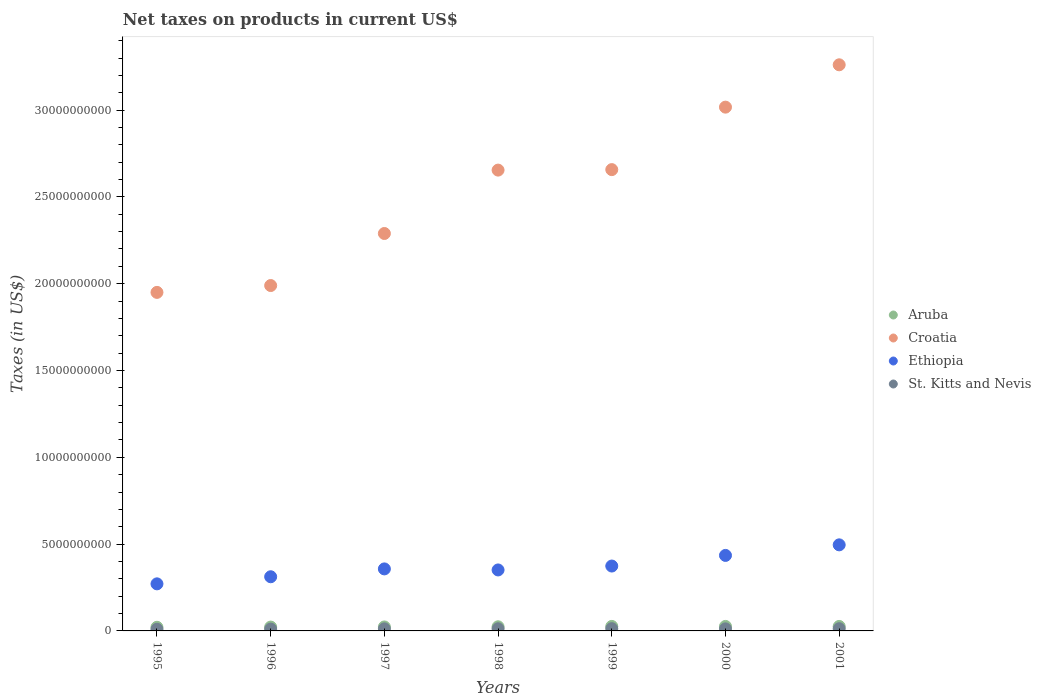Is the number of dotlines equal to the number of legend labels?
Provide a succinct answer. Yes. What is the net taxes on products in Croatia in 1995?
Make the answer very short. 1.95e+1. Across all years, what is the maximum net taxes on products in Aruba?
Your answer should be compact. 2.59e+08. Across all years, what is the minimum net taxes on products in Aruba?
Offer a very short reply. 2.09e+08. What is the total net taxes on products in Aruba in the graph?
Your response must be concise. 1.67e+09. What is the difference between the net taxes on products in Croatia in 2000 and that in 2001?
Keep it short and to the point. -2.44e+09. What is the difference between the net taxes on products in Croatia in 1995 and the net taxes on products in Ethiopia in 2001?
Your answer should be very brief. 1.45e+1. What is the average net taxes on products in Aruba per year?
Your response must be concise. 2.39e+08. In the year 1997, what is the difference between the net taxes on products in Ethiopia and net taxes on products in St. Kitts and Nevis?
Your answer should be compact. 3.45e+09. In how many years, is the net taxes on products in Aruba greater than 8000000000 US$?
Your answer should be very brief. 0. What is the ratio of the net taxes on products in Ethiopia in 1996 to that in 1999?
Offer a terse response. 0.83. Is the difference between the net taxes on products in Ethiopia in 1996 and 1999 greater than the difference between the net taxes on products in St. Kitts and Nevis in 1996 and 1999?
Make the answer very short. No. What is the difference between the highest and the second highest net taxes on products in St. Kitts and Nevis?
Your answer should be very brief. 2.08e+06. What is the difference between the highest and the lowest net taxes on products in St. Kitts and Nevis?
Offer a terse response. 3.42e+07. Is the sum of the net taxes on products in Croatia in 1997 and 2001 greater than the maximum net taxes on products in Ethiopia across all years?
Offer a terse response. Yes. Is it the case that in every year, the sum of the net taxes on products in St. Kitts and Nevis and net taxes on products in Ethiopia  is greater than the net taxes on products in Aruba?
Ensure brevity in your answer.  Yes. Does the net taxes on products in St. Kitts and Nevis monotonically increase over the years?
Provide a short and direct response. No. Is the net taxes on products in Ethiopia strictly greater than the net taxes on products in St. Kitts and Nevis over the years?
Give a very brief answer. Yes. Is the net taxes on products in St. Kitts and Nevis strictly less than the net taxes on products in Croatia over the years?
Keep it short and to the point. Yes. Does the graph contain grids?
Offer a very short reply. No. What is the title of the graph?
Your answer should be very brief. Net taxes on products in current US$. Does "Virgin Islands" appear as one of the legend labels in the graph?
Make the answer very short. No. What is the label or title of the Y-axis?
Keep it short and to the point. Taxes (in US$). What is the Taxes (in US$) in Aruba in 1995?
Make the answer very short. 2.09e+08. What is the Taxes (in US$) in Croatia in 1995?
Your answer should be compact. 1.95e+1. What is the Taxes (in US$) of Ethiopia in 1995?
Your response must be concise. 2.71e+09. What is the Taxes (in US$) in St. Kitts and Nevis in 1995?
Offer a very short reply. 9.47e+07. What is the Taxes (in US$) of Aruba in 1996?
Make the answer very short. 2.21e+08. What is the Taxes (in US$) of Croatia in 1996?
Give a very brief answer. 1.99e+1. What is the Taxes (in US$) in Ethiopia in 1996?
Make the answer very short. 3.12e+09. What is the Taxes (in US$) in St. Kitts and Nevis in 1996?
Provide a short and direct response. 1.05e+08. What is the Taxes (in US$) of Aruba in 1997?
Your answer should be compact. 2.29e+08. What is the Taxes (in US$) of Croatia in 1997?
Your answer should be compact. 2.29e+1. What is the Taxes (in US$) in Ethiopia in 1997?
Keep it short and to the point. 3.57e+09. What is the Taxes (in US$) of St. Kitts and Nevis in 1997?
Provide a succinct answer. 1.19e+08. What is the Taxes (in US$) of Aruba in 1998?
Provide a short and direct response. 2.38e+08. What is the Taxes (in US$) in Croatia in 1998?
Offer a very short reply. 2.65e+1. What is the Taxes (in US$) in Ethiopia in 1998?
Make the answer very short. 3.51e+09. What is the Taxes (in US$) of St. Kitts and Nevis in 1998?
Offer a terse response. 1.23e+08. What is the Taxes (in US$) of Aruba in 1999?
Make the answer very short. 2.59e+08. What is the Taxes (in US$) in Croatia in 1999?
Your answer should be very brief. 2.66e+1. What is the Taxes (in US$) of Ethiopia in 1999?
Offer a very short reply. 3.74e+09. What is the Taxes (in US$) in St. Kitts and Nevis in 1999?
Provide a succinct answer. 1.29e+08. What is the Taxes (in US$) in Aruba in 2000?
Your answer should be very brief. 2.59e+08. What is the Taxes (in US$) of Croatia in 2000?
Ensure brevity in your answer.  3.02e+1. What is the Taxes (in US$) in Ethiopia in 2000?
Your answer should be compact. 4.35e+09. What is the Taxes (in US$) in St. Kitts and Nevis in 2000?
Give a very brief answer. 1.19e+08. What is the Taxes (in US$) in Aruba in 2001?
Your answer should be compact. 2.58e+08. What is the Taxes (in US$) of Croatia in 2001?
Provide a succinct answer. 3.26e+1. What is the Taxes (in US$) in Ethiopia in 2001?
Offer a terse response. 4.96e+09. What is the Taxes (in US$) of St. Kitts and Nevis in 2001?
Ensure brevity in your answer.  1.27e+08. Across all years, what is the maximum Taxes (in US$) in Aruba?
Your answer should be compact. 2.59e+08. Across all years, what is the maximum Taxes (in US$) in Croatia?
Provide a short and direct response. 3.26e+1. Across all years, what is the maximum Taxes (in US$) in Ethiopia?
Ensure brevity in your answer.  4.96e+09. Across all years, what is the maximum Taxes (in US$) of St. Kitts and Nevis?
Offer a terse response. 1.29e+08. Across all years, what is the minimum Taxes (in US$) of Aruba?
Provide a short and direct response. 2.09e+08. Across all years, what is the minimum Taxes (in US$) of Croatia?
Give a very brief answer. 1.95e+1. Across all years, what is the minimum Taxes (in US$) of Ethiopia?
Keep it short and to the point. 2.71e+09. Across all years, what is the minimum Taxes (in US$) of St. Kitts and Nevis?
Provide a succinct answer. 9.47e+07. What is the total Taxes (in US$) in Aruba in the graph?
Provide a short and direct response. 1.67e+09. What is the total Taxes (in US$) of Croatia in the graph?
Provide a short and direct response. 1.78e+11. What is the total Taxes (in US$) in Ethiopia in the graph?
Provide a short and direct response. 2.60e+1. What is the total Taxes (in US$) of St. Kitts and Nevis in the graph?
Provide a succinct answer. 8.17e+08. What is the difference between the Taxes (in US$) of Aruba in 1995 and that in 1996?
Keep it short and to the point. -1.20e+07. What is the difference between the Taxes (in US$) of Croatia in 1995 and that in 1996?
Your answer should be compact. -3.94e+08. What is the difference between the Taxes (in US$) in Ethiopia in 1995 and that in 1996?
Offer a very short reply. -4.08e+08. What is the difference between the Taxes (in US$) in St. Kitts and Nevis in 1995 and that in 1996?
Provide a short and direct response. -1.04e+07. What is the difference between the Taxes (in US$) in Aruba in 1995 and that in 1997?
Provide a succinct answer. -2.00e+07. What is the difference between the Taxes (in US$) of Croatia in 1995 and that in 1997?
Give a very brief answer. -3.39e+09. What is the difference between the Taxes (in US$) in Ethiopia in 1995 and that in 1997?
Offer a very short reply. -8.61e+08. What is the difference between the Taxes (in US$) of St. Kitts and Nevis in 1995 and that in 1997?
Your answer should be very brief. -2.41e+07. What is the difference between the Taxes (in US$) in Aruba in 1995 and that in 1998?
Keep it short and to the point. -2.95e+07. What is the difference between the Taxes (in US$) in Croatia in 1995 and that in 1998?
Offer a very short reply. -7.04e+09. What is the difference between the Taxes (in US$) of Ethiopia in 1995 and that in 1998?
Offer a very short reply. -8.01e+08. What is the difference between the Taxes (in US$) of St. Kitts and Nevis in 1995 and that in 1998?
Your answer should be compact. -2.86e+07. What is the difference between the Taxes (in US$) in Aruba in 1995 and that in 1999?
Make the answer very short. -4.98e+07. What is the difference between the Taxes (in US$) in Croatia in 1995 and that in 1999?
Provide a succinct answer. -7.07e+09. What is the difference between the Taxes (in US$) in Ethiopia in 1995 and that in 1999?
Make the answer very short. -1.03e+09. What is the difference between the Taxes (in US$) of St. Kitts and Nevis in 1995 and that in 1999?
Your answer should be compact. -3.42e+07. What is the difference between the Taxes (in US$) in Aruba in 1995 and that in 2000?
Your answer should be compact. -4.98e+07. What is the difference between the Taxes (in US$) in Croatia in 1995 and that in 2000?
Make the answer very short. -1.07e+1. What is the difference between the Taxes (in US$) of Ethiopia in 1995 and that in 2000?
Make the answer very short. -1.64e+09. What is the difference between the Taxes (in US$) of St. Kitts and Nevis in 1995 and that in 2000?
Ensure brevity in your answer.  -2.39e+07. What is the difference between the Taxes (in US$) of Aruba in 1995 and that in 2001?
Keep it short and to the point. -4.92e+07. What is the difference between the Taxes (in US$) of Croatia in 1995 and that in 2001?
Your answer should be very brief. -1.31e+1. What is the difference between the Taxes (in US$) in Ethiopia in 1995 and that in 2001?
Ensure brevity in your answer.  -2.25e+09. What is the difference between the Taxes (in US$) of St. Kitts and Nevis in 1995 and that in 2001?
Keep it short and to the point. -3.21e+07. What is the difference between the Taxes (in US$) of Aruba in 1996 and that in 1997?
Provide a short and direct response. -8.00e+06. What is the difference between the Taxes (in US$) in Croatia in 1996 and that in 1997?
Offer a very short reply. -3.00e+09. What is the difference between the Taxes (in US$) in Ethiopia in 1996 and that in 1997?
Offer a very short reply. -4.52e+08. What is the difference between the Taxes (in US$) of St. Kitts and Nevis in 1996 and that in 1997?
Ensure brevity in your answer.  -1.37e+07. What is the difference between the Taxes (in US$) in Aruba in 1996 and that in 1998?
Provide a short and direct response. -1.75e+07. What is the difference between the Taxes (in US$) of Croatia in 1996 and that in 1998?
Provide a short and direct response. -6.65e+09. What is the difference between the Taxes (in US$) in Ethiopia in 1996 and that in 1998?
Give a very brief answer. -3.92e+08. What is the difference between the Taxes (in US$) in St. Kitts and Nevis in 1996 and that in 1998?
Offer a very short reply. -1.82e+07. What is the difference between the Taxes (in US$) in Aruba in 1996 and that in 1999?
Provide a succinct answer. -3.78e+07. What is the difference between the Taxes (in US$) of Croatia in 1996 and that in 1999?
Give a very brief answer. -6.68e+09. What is the difference between the Taxes (in US$) of Ethiopia in 1996 and that in 1999?
Ensure brevity in your answer.  -6.17e+08. What is the difference between the Taxes (in US$) of St. Kitts and Nevis in 1996 and that in 1999?
Make the answer very short. -2.38e+07. What is the difference between the Taxes (in US$) of Aruba in 1996 and that in 2000?
Make the answer very short. -3.78e+07. What is the difference between the Taxes (in US$) in Croatia in 1996 and that in 2000?
Your response must be concise. -1.03e+1. What is the difference between the Taxes (in US$) of Ethiopia in 1996 and that in 2000?
Your answer should be very brief. -1.23e+09. What is the difference between the Taxes (in US$) in St. Kitts and Nevis in 1996 and that in 2000?
Give a very brief answer. -1.35e+07. What is the difference between the Taxes (in US$) of Aruba in 1996 and that in 2001?
Give a very brief answer. -3.72e+07. What is the difference between the Taxes (in US$) in Croatia in 1996 and that in 2001?
Provide a short and direct response. -1.27e+1. What is the difference between the Taxes (in US$) in Ethiopia in 1996 and that in 2001?
Your answer should be very brief. -1.84e+09. What is the difference between the Taxes (in US$) of St. Kitts and Nevis in 1996 and that in 2001?
Give a very brief answer. -2.17e+07. What is the difference between the Taxes (in US$) in Aruba in 1997 and that in 1998?
Offer a very short reply. -9.46e+06. What is the difference between the Taxes (in US$) of Croatia in 1997 and that in 1998?
Your response must be concise. -3.65e+09. What is the difference between the Taxes (in US$) in Ethiopia in 1997 and that in 1998?
Provide a succinct answer. 5.98e+07. What is the difference between the Taxes (in US$) of St. Kitts and Nevis in 1997 and that in 1998?
Ensure brevity in your answer.  -4.53e+06. What is the difference between the Taxes (in US$) in Aruba in 1997 and that in 1999?
Your answer should be very brief. -2.98e+07. What is the difference between the Taxes (in US$) of Croatia in 1997 and that in 1999?
Offer a terse response. -3.68e+09. What is the difference between the Taxes (in US$) of Ethiopia in 1997 and that in 1999?
Keep it short and to the point. -1.65e+08. What is the difference between the Taxes (in US$) of St. Kitts and Nevis in 1997 and that in 1999?
Give a very brief answer. -1.01e+07. What is the difference between the Taxes (in US$) in Aruba in 1997 and that in 2000?
Your response must be concise. -2.98e+07. What is the difference between the Taxes (in US$) in Croatia in 1997 and that in 2000?
Offer a very short reply. -7.28e+09. What is the difference between the Taxes (in US$) of Ethiopia in 1997 and that in 2000?
Your response must be concise. -7.77e+08. What is the difference between the Taxes (in US$) in Aruba in 1997 and that in 2001?
Your response must be concise. -2.92e+07. What is the difference between the Taxes (in US$) of Croatia in 1997 and that in 2001?
Offer a very short reply. -9.72e+09. What is the difference between the Taxes (in US$) of Ethiopia in 1997 and that in 2001?
Ensure brevity in your answer.  -1.39e+09. What is the difference between the Taxes (in US$) in St. Kitts and Nevis in 1997 and that in 2001?
Give a very brief answer. -8.01e+06. What is the difference between the Taxes (in US$) of Aruba in 1998 and that in 1999?
Give a very brief answer. -2.03e+07. What is the difference between the Taxes (in US$) of Croatia in 1998 and that in 1999?
Give a very brief answer. -2.80e+07. What is the difference between the Taxes (in US$) of Ethiopia in 1998 and that in 1999?
Your response must be concise. -2.25e+08. What is the difference between the Taxes (in US$) of St. Kitts and Nevis in 1998 and that in 1999?
Your response must be concise. -5.56e+06. What is the difference between the Taxes (in US$) of Aruba in 1998 and that in 2000?
Give a very brief answer. -2.03e+07. What is the difference between the Taxes (in US$) of Croatia in 1998 and that in 2000?
Keep it short and to the point. -3.63e+09. What is the difference between the Taxes (in US$) of Ethiopia in 1998 and that in 2000?
Your answer should be compact. -8.37e+08. What is the difference between the Taxes (in US$) of St. Kitts and Nevis in 1998 and that in 2000?
Give a very brief answer. 4.72e+06. What is the difference between the Taxes (in US$) in Aruba in 1998 and that in 2001?
Keep it short and to the point. -1.97e+07. What is the difference between the Taxes (in US$) in Croatia in 1998 and that in 2001?
Provide a succinct answer. -6.07e+09. What is the difference between the Taxes (in US$) of Ethiopia in 1998 and that in 2001?
Offer a very short reply. -1.45e+09. What is the difference between the Taxes (in US$) of St. Kitts and Nevis in 1998 and that in 2001?
Your answer should be compact. -3.48e+06. What is the difference between the Taxes (in US$) of Aruba in 1999 and that in 2000?
Your answer should be very brief. 0. What is the difference between the Taxes (in US$) of Croatia in 1999 and that in 2000?
Offer a terse response. -3.60e+09. What is the difference between the Taxes (in US$) in Ethiopia in 1999 and that in 2000?
Offer a very short reply. -6.12e+08. What is the difference between the Taxes (in US$) of St. Kitts and Nevis in 1999 and that in 2000?
Offer a terse response. 1.03e+07. What is the difference between the Taxes (in US$) in Aruba in 1999 and that in 2001?
Your response must be concise. 5.80e+05. What is the difference between the Taxes (in US$) of Croatia in 1999 and that in 2001?
Provide a short and direct response. -6.04e+09. What is the difference between the Taxes (in US$) of Ethiopia in 1999 and that in 2001?
Offer a terse response. -1.22e+09. What is the difference between the Taxes (in US$) of St. Kitts and Nevis in 1999 and that in 2001?
Offer a terse response. 2.08e+06. What is the difference between the Taxes (in US$) of Aruba in 2000 and that in 2001?
Make the answer very short. 5.80e+05. What is the difference between the Taxes (in US$) of Croatia in 2000 and that in 2001?
Keep it short and to the point. -2.44e+09. What is the difference between the Taxes (in US$) of Ethiopia in 2000 and that in 2001?
Ensure brevity in your answer.  -6.09e+08. What is the difference between the Taxes (in US$) in St. Kitts and Nevis in 2000 and that in 2001?
Ensure brevity in your answer.  -8.20e+06. What is the difference between the Taxes (in US$) of Aruba in 1995 and the Taxes (in US$) of Croatia in 1996?
Keep it short and to the point. -1.97e+1. What is the difference between the Taxes (in US$) in Aruba in 1995 and the Taxes (in US$) in Ethiopia in 1996?
Offer a very short reply. -2.91e+09. What is the difference between the Taxes (in US$) of Aruba in 1995 and the Taxes (in US$) of St. Kitts and Nevis in 1996?
Your response must be concise. 1.04e+08. What is the difference between the Taxes (in US$) in Croatia in 1995 and the Taxes (in US$) in Ethiopia in 1996?
Make the answer very short. 1.64e+1. What is the difference between the Taxes (in US$) of Croatia in 1995 and the Taxes (in US$) of St. Kitts and Nevis in 1996?
Keep it short and to the point. 1.94e+1. What is the difference between the Taxes (in US$) in Ethiopia in 1995 and the Taxes (in US$) in St. Kitts and Nevis in 1996?
Your response must be concise. 2.61e+09. What is the difference between the Taxes (in US$) of Aruba in 1995 and the Taxes (in US$) of Croatia in 1997?
Your answer should be very brief. -2.27e+1. What is the difference between the Taxes (in US$) in Aruba in 1995 and the Taxes (in US$) in Ethiopia in 1997?
Provide a short and direct response. -3.36e+09. What is the difference between the Taxes (in US$) in Aruba in 1995 and the Taxes (in US$) in St. Kitts and Nevis in 1997?
Make the answer very short. 9.02e+07. What is the difference between the Taxes (in US$) in Croatia in 1995 and the Taxes (in US$) in Ethiopia in 1997?
Your response must be concise. 1.59e+1. What is the difference between the Taxes (in US$) in Croatia in 1995 and the Taxes (in US$) in St. Kitts and Nevis in 1997?
Provide a succinct answer. 1.94e+1. What is the difference between the Taxes (in US$) of Ethiopia in 1995 and the Taxes (in US$) of St. Kitts and Nevis in 1997?
Your answer should be compact. 2.59e+09. What is the difference between the Taxes (in US$) of Aruba in 1995 and the Taxes (in US$) of Croatia in 1998?
Offer a terse response. -2.63e+1. What is the difference between the Taxes (in US$) of Aruba in 1995 and the Taxes (in US$) of Ethiopia in 1998?
Provide a short and direct response. -3.30e+09. What is the difference between the Taxes (in US$) in Aruba in 1995 and the Taxes (in US$) in St. Kitts and Nevis in 1998?
Keep it short and to the point. 8.56e+07. What is the difference between the Taxes (in US$) in Croatia in 1995 and the Taxes (in US$) in Ethiopia in 1998?
Your response must be concise. 1.60e+1. What is the difference between the Taxes (in US$) of Croatia in 1995 and the Taxes (in US$) of St. Kitts and Nevis in 1998?
Make the answer very short. 1.94e+1. What is the difference between the Taxes (in US$) in Ethiopia in 1995 and the Taxes (in US$) in St. Kitts and Nevis in 1998?
Offer a terse response. 2.59e+09. What is the difference between the Taxes (in US$) of Aruba in 1995 and the Taxes (in US$) of Croatia in 1999?
Your response must be concise. -2.64e+1. What is the difference between the Taxes (in US$) in Aruba in 1995 and the Taxes (in US$) in Ethiopia in 1999?
Ensure brevity in your answer.  -3.53e+09. What is the difference between the Taxes (in US$) of Aruba in 1995 and the Taxes (in US$) of St. Kitts and Nevis in 1999?
Provide a succinct answer. 8.01e+07. What is the difference between the Taxes (in US$) of Croatia in 1995 and the Taxes (in US$) of Ethiopia in 1999?
Ensure brevity in your answer.  1.58e+1. What is the difference between the Taxes (in US$) of Croatia in 1995 and the Taxes (in US$) of St. Kitts and Nevis in 1999?
Your answer should be very brief. 1.94e+1. What is the difference between the Taxes (in US$) in Ethiopia in 1995 and the Taxes (in US$) in St. Kitts and Nevis in 1999?
Offer a very short reply. 2.58e+09. What is the difference between the Taxes (in US$) in Aruba in 1995 and the Taxes (in US$) in Croatia in 2000?
Offer a terse response. -3.00e+1. What is the difference between the Taxes (in US$) in Aruba in 1995 and the Taxes (in US$) in Ethiopia in 2000?
Ensure brevity in your answer.  -4.14e+09. What is the difference between the Taxes (in US$) in Aruba in 1995 and the Taxes (in US$) in St. Kitts and Nevis in 2000?
Your answer should be compact. 9.04e+07. What is the difference between the Taxes (in US$) of Croatia in 1995 and the Taxes (in US$) of Ethiopia in 2000?
Give a very brief answer. 1.52e+1. What is the difference between the Taxes (in US$) in Croatia in 1995 and the Taxes (in US$) in St. Kitts and Nevis in 2000?
Your answer should be compact. 1.94e+1. What is the difference between the Taxes (in US$) of Ethiopia in 1995 and the Taxes (in US$) of St. Kitts and Nevis in 2000?
Make the answer very short. 2.59e+09. What is the difference between the Taxes (in US$) in Aruba in 1995 and the Taxes (in US$) in Croatia in 2001?
Make the answer very short. -3.24e+1. What is the difference between the Taxes (in US$) in Aruba in 1995 and the Taxes (in US$) in Ethiopia in 2001?
Ensure brevity in your answer.  -4.75e+09. What is the difference between the Taxes (in US$) of Aruba in 1995 and the Taxes (in US$) of St. Kitts and Nevis in 2001?
Keep it short and to the point. 8.22e+07. What is the difference between the Taxes (in US$) of Croatia in 1995 and the Taxes (in US$) of Ethiopia in 2001?
Make the answer very short. 1.45e+1. What is the difference between the Taxes (in US$) of Croatia in 1995 and the Taxes (in US$) of St. Kitts and Nevis in 2001?
Your answer should be very brief. 1.94e+1. What is the difference between the Taxes (in US$) of Ethiopia in 1995 and the Taxes (in US$) of St. Kitts and Nevis in 2001?
Your response must be concise. 2.58e+09. What is the difference between the Taxes (in US$) in Aruba in 1996 and the Taxes (in US$) in Croatia in 1997?
Provide a short and direct response. -2.27e+1. What is the difference between the Taxes (in US$) of Aruba in 1996 and the Taxes (in US$) of Ethiopia in 1997?
Make the answer very short. -3.35e+09. What is the difference between the Taxes (in US$) in Aruba in 1996 and the Taxes (in US$) in St. Kitts and Nevis in 1997?
Offer a very short reply. 1.02e+08. What is the difference between the Taxes (in US$) of Croatia in 1996 and the Taxes (in US$) of Ethiopia in 1997?
Offer a terse response. 1.63e+1. What is the difference between the Taxes (in US$) in Croatia in 1996 and the Taxes (in US$) in St. Kitts and Nevis in 1997?
Offer a terse response. 1.98e+1. What is the difference between the Taxes (in US$) of Ethiopia in 1996 and the Taxes (in US$) of St. Kitts and Nevis in 1997?
Ensure brevity in your answer.  3.00e+09. What is the difference between the Taxes (in US$) of Aruba in 1996 and the Taxes (in US$) of Croatia in 1998?
Ensure brevity in your answer.  -2.63e+1. What is the difference between the Taxes (in US$) of Aruba in 1996 and the Taxes (in US$) of Ethiopia in 1998?
Give a very brief answer. -3.29e+09. What is the difference between the Taxes (in US$) of Aruba in 1996 and the Taxes (in US$) of St. Kitts and Nevis in 1998?
Your response must be concise. 9.76e+07. What is the difference between the Taxes (in US$) in Croatia in 1996 and the Taxes (in US$) in Ethiopia in 1998?
Keep it short and to the point. 1.64e+1. What is the difference between the Taxes (in US$) of Croatia in 1996 and the Taxes (in US$) of St. Kitts and Nevis in 1998?
Ensure brevity in your answer.  1.98e+1. What is the difference between the Taxes (in US$) in Ethiopia in 1996 and the Taxes (in US$) in St. Kitts and Nevis in 1998?
Provide a succinct answer. 3.00e+09. What is the difference between the Taxes (in US$) in Aruba in 1996 and the Taxes (in US$) in Croatia in 1999?
Make the answer very short. -2.63e+1. What is the difference between the Taxes (in US$) of Aruba in 1996 and the Taxes (in US$) of Ethiopia in 1999?
Make the answer very short. -3.52e+09. What is the difference between the Taxes (in US$) in Aruba in 1996 and the Taxes (in US$) in St. Kitts and Nevis in 1999?
Your answer should be very brief. 9.21e+07. What is the difference between the Taxes (in US$) of Croatia in 1996 and the Taxes (in US$) of Ethiopia in 1999?
Offer a terse response. 1.62e+1. What is the difference between the Taxes (in US$) of Croatia in 1996 and the Taxes (in US$) of St. Kitts and Nevis in 1999?
Offer a terse response. 1.98e+1. What is the difference between the Taxes (in US$) in Ethiopia in 1996 and the Taxes (in US$) in St. Kitts and Nevis in 1999?
Offer a very short reply. 2.99e+09. What is the difference between the Taxes (in US$) in Aruba in 1996 and the Taxes (in US$) in Croatia in 2000?
Offer a terse response. -2.99e+1. What is the difference between the Taxes (in US$) of Aruba in 1996 and the Taxes (in US$) of Ethiopia in 2000?
Offer a terse response. -4.13e+09. What is the difference between the Taxes (in US$) in Aruba in 1996 and the Taxes (in US$) in St. Kitts and Nevis in 2000?
Ensure brevity in your answer.  1.02e+08. What is the difference between the Taxes (in US$) in Croatia in 1996 and the Taxes (in US$) in Ethiopia in 2000?
Your answer should be compact. 1.55e+1. What is the difference between the Taxes (in US$) in Croatia in 1996 and the Taxes (in US$) in St. Kitts and Nevis in 2000?
Make the answer very short. 1.98e+1. What is the difference between the Taxes (in US$) in Ethiopia in 1996 and the Taxes (in US$) in St. Kitts and Nevis in 2000?
Provide a succinct answer. 3.00e+09. What is the difference between the Taxes (in US$) in Aruba in 1996 and the Taxes (in US$) in Croatia in 2001?
Provide a succinct answer. -3.24e+1. What is the difference between the Taxes (in US$) of Aruba in 1996 and the Taxes (in US$) of Ethiopia in 2001?
Ensure brevity in your answer.  -4.74e+09. What is the difference between the Taxes (in US$) in Aruba in 1996 and the Taxes (in US$) in St. Kitts and Nevis in 2001?
Give a very brief answer. 9.42e+07. What is the difference between the Taxes (in US$) in Croatia in 1996 and the Taxes (in US$) in Ethiopia in 2001?
Your response must be concise. 1.49e+1. What is the difference between the Taxes (in US$) in Croatia in 1996 and the Taxes (in US$) in St. Kitts and Nevis in 2001?
Provide a succinct answer. 1.98e+1. What is the difference between the Taxes (in US$) in Ethiopia in 1996 and the Taxes (in US$) in St. Kitts and Nevis in 2001?
Make the answer very short. 2.99e+09. What is the difference between the Taxes (in US$) in Aruba in 1997 and the Taxes (in US$) in Croatia in 1998?
Your answer should be compact. -2.63e+1. What is the difference between the Taxes (in US$) of Aruba in 1997 and the Taxes (in US$) of Ethiopia in 1998?
Provide a succinct answer. -3.28e+09. What is the difference between the Taxes (in US$) in Aruba in 1997 and the Taxes (in US$) in St. Kitts and Nevis in 1998?
Keep it short and to the point. 1.06e+08. What is the difference between the Taxes (in US$) of Croatia in 1997 and the Taxes (in US$) of Ethiopia in 1998?
Offer a terse response. 1.94e+1. What is the difference between the Taxes (in US$) of Croatia in 1997 and the Taxes (in US$) of St. Kitts and Nevis in 1998?
Ensure brevity in your answer.  2.28e+1. What is the difference between the Taxes (in US$) of Ethiopia in 1997 and the Taxes (in US$) of St. Kitts and Nevis in 1998?
Offer a terse response. 3.45e+09. What is the difference between the Taxes (in US$) of Aruba in 1997 and the Taxes (in US$) of Croatia in 1999?
Your answer should be very brief. -2.63e+1. What is the difference between the Taxes (in US$) of Aruba in 1997 and the Taxes (in US$) of Ethiopia in 1999?
Make the answer very short. -3.51e+09. What is the difference between the Taxes (in US$) in Aruba in 1997 and the Taxes (in US$) in St. Kitts and Nevis in 1999?
Offer a terse response. 1.00e+08. What is the difference between the Taxes (in US$) of Croatia in 1997 and the Taxes (in US$) of Ethiopia in 1999?
Ensure brevity in your answer.  1.92e+1. What is the difference between the Taxes (in US$) of Croatia in 1997 and the Taxes (in US$) of St. Kitts and Nevis in 1999?
Provide a short and direct response. 2.28e+1. What is the difference between the Taxes (in US$) of Ethiopia in 1997 and the Taxes (in US$) of St. Kitts and Nevis in 1999?
Your response must be concise. 3.44e+09. What is the difference between the Taxes (in US$) of Aruba in 1997 and the Taxes (in US$) of Croatia in 2000?
Make the answer very short. -2.99e+1. What is the difference between the Taxes (in US$) of Aruba in 1997 and the Taxes (in US$) of Ethiopia in 2000?
Your answer should be compact. -4.12e+09. What is the difference between the Taxes (in US$) in Aruba in 1997 and the Taxes (in US$) in St. Kitts and Nevis in 2000?
Offer a very short reply. 1.10e+08. What is the difference between the Taxes (in US$) in Croatia in 1997 and the Taxes (in US$) in Ethiopia in 2000?
Give a very brief answer. 1.85e+1. What is the difference between the Taxes (in US$) in Croatia in 1997 and the Taxes (in US$) in St. Kitts and Nevis in 2000?
Your response must be concise. 2.28e+1. What is the difference between the Taxes (in US$) of Ethiopia in 1997 and the Taxes (in US$) of St. Kitts and Nevis in 2000?
Keep it short and to the point. 3.45e+09. What is the difference between the Taxes (in US$) in Aruba in 1997 and the Taxes (in US$) in Croatia in 2001?
Keep it short and to the point. -3.24e+1. What is the difference between the Taxes (in US$) in Aruba in 1997 and the Taxes (in US$) in Ethiopia in 2001?
Give a very brief answer. -4.73e+09. What is the difference between the Taxes (in US$) of Aruba in 1997 and the Taxes (in US$) of St. Kitts and Nevis in 2001?
Your answer should be very brief. 1.02e+08. What is the difference between the Taxes (in US$) in Croatia in 1997 and the Taxes (in US$) in Ethiopia in 2001?
Your response must be concise. 1.79e+1. What is the difference between the Taxes (in US$) in Croatia in 1997 and the Taxes (in US$) in St. Kitts and Nevis in 2001?
Ensure brevity in your answer.  2.28e+1. What is the difference between the Taxes (in US$) in Ethiopia in 1997 and the Taxes (in US$) in St. Kitts and Nevis in 2001?
Offer a very short reply. 3.45e+09. What is the difference between the Taxes (in US$) of Aruba in 1998 and the Taxes (in US$) of Croatia in 1999?
Make the answer very short. -2.63e+1. What is the difference between the Taxes (in US$) in Aruba in 1998 and the Taxes (in US$) in Ethiopia in 1999?
Your response must be concise. -3.50e+09. What is the difference between the Taxes (in US$) in Aruba in 1998 and the Taxes (in US$) in St. Kitts and Nevis in 1999?
Provide a succinct answer. 1.10e+08. What is the difference between the Taxes (in US$) of Croatia in 1998 and the Taxes (in US$) of Ethiopia in 1999?
Make the answer very short. 2.28e+1. What is the difference between the Taxes (in US$) of Croatia in 1998 and the Taxes (in US$) of St. Kitts and Nevis in 1999?
Provide a short and direct response. 2.64e+1. What is the difference between the Taxes (in US$) of Ethiopia in 1998 and the Taxes (in US$) of St. Kitts and Nevis in 1999?
Make the answer very short. 3.38e+09. What is the difference between the Taxes (in US$) in Aruba in 1998 and the Taxes (in US$) in Croatia in 2000?
Your answer should be compact. -2.99e+1. What is the difference between the Taxes (in US$) of Aruba in 1998 and the Taxes (in US$) of Ethiopia in 2000?
Make the answer very short. -4.11e+09. What is the difference between the Taxes (in US$) of Aruba in 1998 and the Taxes (in US$) of St. Kitts and Nevis in 2000?
Make the answer very short. 1.20e+08. What is the difference between the Taxes (in US$) of Croatia in 1998 and the Taxes (in US$) of Ethiopia in 2000?
Provide a short and direct response. 2.22e+1. What is the difference between the Taxes (in US$) in Croatia in 1998 and the Taxes (in US$) in St. Kitts and Nevis in 2000?
Offer a very short reply. 2.64e+1. What is the difference between the Taxes (in US$) in Ethiopia in 1998 and the Taxes (in US$) in St. Kitts and Nevis in 2000?
Ensure brevity in your answer.  3.39e+09. What is the difference between the Taxes (in US$) in Aruba in 1998 and the Taxes (in US$) in Croatia in 2001?
Keep it short and to the point. -3.24e+1. What is the difference between the Taxes (in US$) of Aruba in 1998 and the Taxes (in US$) of Ethiopia in 2001?
Ensure brevity in your answer.  -4.72e+09. What is the difference between the Taxes (in US$) of Aruba in 1998 and the Taxes (in US$) of St. Kitts and Nevis in 2001?
Provide a short and direct response. 1.12e+08. What is the difference between the Taxes (in US$) of Croatia in 1998 and the Taxes (in US$) of Ethiopia in 2001?
Offer a very short reply. 2.16e+1. What is the difference between the Taxes (in US$) in Croatia in 1998 and the Taxes (in US$) in St. Kitts and Nevis in 2001?
Your answer should be very brief. 2.64e+1. What is the difference between the Taxes (in US$) in Ethiopia in 1998 and the Taxes (in US$) in St. Kitts and Nevis in 2001?
Offer a very short reply. 3.39e+09. What is the difference between the Taxes (in US$) of Aruba in 1999 and the Taxes (in US$) of Croatia in 2000?
Provide a succinct answer. -2.99e+1. What is the difference between the Taxes (in US$) of Aruba in 1999 and the Taxes (in US$) of Ethiopia in 2000?
Ensure brevity in your answer.  -4.09e+09. What is the difference between the Taxes (in US$) in Aruba in 1999 and the Taxes (in US$) in St. Kitts and Nevis in 2000?
Offer a terse response. 1.40e+08. What is the difference between the Taxes (in US$) of Croatia in 1999 and the Taxes (in US$) of Ethiopia in 2000?
Your response must be concise. 2.22e+1. What is the difference between the Taxes (in US$) of Croatia in 1999 and the Taxes (in US$) of St. Kitts and Nevis in 2000?
Offer a very short reply. 2.65e+1. What is the difference between the Taxes (in US$) of Ethiopia in 1999 and the Taxes (in US$) of St. Kitts and Nevis in 2000?
Your response must be concise. 3.62e+09. What is the difference between the Taxes (in US$) of Aruba in 1999 and the Taxes (in US$) of Croatia in 2001?
Your answer should be very brief. -3.23e+1. What is the difference between the Taxes (in US$) in Aruba in 1999 and the Taxes (in US$) in Ethiopia in 2001?
Offer a terse response. -4.70e+09. What is the difference between the Taxes (in US$) in Aruba in 1999 and the Taxes (in US$) in St. Kitts and Nevis in 2001?
Offer a terse response. 1.32e+08. What is the difference between the Taxes (in US$) in Croatia in 1999 and the Taxes (in US$) in Ethiopia in 2001?
Offer a terse response. 2.16e+1. What is the difference between the Taxes (in US$) of Croatia in 1999 and the Taxes (in US$) of St. Kitts and Nevis in 2001?
Ensure brevity in your answer.  2.64e+1. What is the difference between the Taxes (in US$) of Ethiopia in 1999 and the Taxes (in US$) of St. Kitts and Nevis in 2001?
Offer a terse response. 3.61e+09. What is the difference between the Taxes (in US$) of Aruba in 2000 and the Taxes (in US$) of Croatia in 2001?
Make the answer very short. -3.23e+1. What is the difference between the Taxes (in US$) of Aruba in 2000 and the Taxes (in US$) of Ethiopia in 2001?
Keep it short and to the point. -4.70e+09. What is the difference between the Taxes (in US$) of Aruba in 2000 and the Taxes (in US$) of St. Kitts and Nevis in 2001?
Your response must be concise. 1.32e+08. What is the difference between the Taxes (in US$) of Croatia in 2000 and the Taxes (in US$) of Ethiopia in 2001?
Provide a succinct answer. 2.52e+1. What is the difference between the Taxes (in US$) of Croatia in 2000 and the Taxes (in US$) of St. Kitts and Nevis in 2001?
Offer a very short reply. 3.00e+1. What is the difference between the Taxes (in US$) of Ethiopia in 2000 and the Taxes (in US$) of St. Kitts and Nevis in 2001?
Your response must be concise. 4.22e+09. What is the average Taxes (in US$) of Aruba per year?
Offer a very short reply. 2.39e+08. What is the average Taxes (in US$) of Croatia per year?
Provide a succinct answer. 2.55e+1. What is the average Taxes (in US$) in Ethiopia per year?
Your answer should be very brief. 3.71e+09. What is the average Taxes (in US$) of St. Kitts and Nevis per year?
Provide a succinct answer. 1.17e+08. In the year 1995, what is the difference between the Taxes (in US$) in Aruba and Taxes (in US$) in Croatia?
Provide a short and direct response. -1.93e+1. In the year 1995, what is the difference between the Taxes (in US$) in Aruba and Taxes (in US$) in Ethiopia?
Give a very brief answer. -2.50e+09. In the year 1995, what is the difference between the Taxes (in US$) of Aruba and Taxes (in US$) of St. Kitts and Nevis?
Provide a short and direct response. 1.14e+08. In the year 1995, what is the difference between the Taxes (in US$) in Croatia and Taxes (in US$) in Ethiopia?
Your answer should be compact. 1.68e+1. In the year 1995, what is the difference between the Taxes (in US$) in Croatia and Taxes (in US$) in St. Kitts and Nevis?
Provide a short and direct response. 1.94e+1. In the year 1995, what is the difference between the Taxes (in US$) of Ethiopia and Taxes (in US$) of St. Kitts and Nevis?
Provide a short and direct response. 2.62e+09. In the year 1996, what is the difference between the Taxes (in US$) of Aruba and Taxes (in US$) of Croatia?
Keep it short and to the point. -1.97e+1. In the year 1996, what is the difference between the Taxes (in US$) of Aruba and Taxes (in US$) of Ethiopia?
Offer a very short reply. -2.90e+09. In the year 1996, what is the difference between the Taxes (in US$) of Aruba and Taxes (in US$) of St. Kitts and Nevis?
Give a very brief answer. 1.16e+08. In the year 1996, what is the difference between the Taxes (in US$) in Croatia and Taxes (in US$) in Ethiopia?
Ensure brevity in your answer.  1.68e+1. In the year 1996, what is the difference between the Taxes (in US$) of Croatia and Taxes (in US$) of St. Kitts and Nevis?
Give a very brief answer. 1.98e+1. In the year 1996, what is the difference between the Taxes (in US$) of Ethiopia and Taxes (in US$) of St. Kitts and Nevis?
Offer a terse response. 3.01e+09. In the year 1997, what is the difference between the Taxes (in US$) in Aruba and Taxes (in US$) in Croatia?
Provide a succinct answer. -2.27e+1. In the year 1997, what is the difference between the Taxes (in US$) in Aruba and Taxes (in US$) in Ethiopia?
Provide a succinct answer. -3.34e+09. In the year 1997, what is the difference between the Taxes (in US$) in Aruba and Taxes (in US$) in St. Kitts and Nevis?
Your answer should be compact. 1.10e+08. In the year 1997, what is the difference between the Taxes (in US$) in Croatia and Taxes (in US$) in Ethiopia?
Your response must be concise. 1.93e+1. In the year 1997, what is the difference between the Taxes (in US$) in Croatia and Taxes (in US$) in St. Kitts and Nevis?
Your answer should be compact. 2.28e+1. In the year 1997, what is the difference between the Taxes (in US$) in Ethiopia and Taxes (in US$) in St. Kitts and Nevis?
Provide a short and direct response. 3.45e+09. In the year 1998, what is the difference between the Taxes (in US$) of Aruba and Taxes (in US$) of Croatia?
Your answer should be very brief. -2.63e+1. In the year 1998, what is the difference between the Taxes (in US$) in Aruba and Taxes (in US$) in Ethiopia?
Provide a short and direct response. -3.27e+09. In the year 1998, what is the difference between the Taxes (in US$) in Aruba and Taxes (in US$) in St. Kitts and Nevis?
Provide a short and direct response. 1.15e+08. In the year 1998, what is the difference between the Taxes (in US$) in Croatia and Taxes (in US$) in Ethiopia?
Give a very brief answer. 2.30e+1. In the year 1998, what is the difference between the Taxes (in US$) of Croatia and Taxes (in US$) of St. Kitts and Nevis?
Offer a very short reply. 2.64e+1. In the year 1998, what is the difference between the Taxes (in US$) of Ethiopia and Taxes (in US$) of St. Kitts and Nevis?
Make the answer very short. 3.39e+09. In the year 1999, what is the difference between the Taxes (in US$) in Aruba and Taxes (in US$) in Croatia?
Provide a succinct answer. -2.63e+1. In the year 1999, what is the difference between the Taxes (in US$) of Aruba and Taxes (in US$) of Ethiopia?
Make the answer very short. -3.48e+09. In the year 1999, what is the difference between the Taxes (in US$) of Aruba and Taxes (in US$) of St. Kitts and Nevis?
Ensure brevity in your answer.  1.30e+08. In the year 1999, what is the difference between the Taxes (in US$) of Croatia and Taxes (in US$) of Ethiopia?
Keep it short and to the point. 2.28e+1. In the year 1999, what is the difference between the Taxes (in US$) of Croatia and Taxes (in US$) of St. Kitts and Nevis?
Your response must be concise. 2.64e+1. In the year 1999, what is the difference between the Taxes (in US$) of Ethiopia and Taxes (in US$) of St. Kitts and Nevis?
Offer a very short reply. 3.61e+09. In the year 2000, what is the difference between the Taxes (in US$) in Aruba and Taxes (in US$) in Croatia?
Ensure brevity in your answer.  -2.99e+1. In the year 2000, what is the difference between the Taxes (in US$) of Aruba and Taxes (in US$) of Ethiopia?
Your answer should be compact. -4.09e+09. In the year 2000, what is the difference between the Taxes (in US$) in Aruba and Taxes (in US$) in St. Kitts and Nevis?
Your response must be concise. 1.40e+08. In the year 2000, what is the difference between the Taxes (in US$) in Croatia and Taxes (in US$) in Ethiopia?
Keep it short and to the point. 2.58e+1. In the year 2000, what is the difference between the Taxes (in US$) in Croatia and Taxes (in US$) in St. Kitts and Nevis?
Offer a terse response. 3.01e+1. In the year 2000, what is the difference between the Taxes (in US$) in Ethiopia and Taxes (in US$) in St. Kitts and Nevis?
Provide a short and direct response. 4.23e+09. In the year 2001, what is the difference between the Taxes (in US$) in Aruba and Taxes (in US$) in Croatia?
Provide a succinct answer. -3.24e+1. In the year 2001, what is the difference between the Taxes (in US$) of Aruba and Taxes (in US$) of Ethiopia?
Give a very brief answer. -4.70e+09. In the year 2001, what is the difference between the Taxes (in US$) in Aruba and Taxes (in US$) in St. Kitts and Nevis?
Ensure brevity in your answer.  1.31e+08. In the year 2001, what is the difference between the Taxes (in US$) of Croatia and Taxes (in US$) of Ethiopia?
Provide a succinct answer. 2.77e+1. In the year 2001, what is the difference between the Taxes (in US$) in Croatia and Taxes (in US$) in St. Kitts and Nevis?
Your response must be concise. 3.25e+1. In the year 2001, what is the difference between the Taxes (in US$) in Ethiopia and Taxes (in US$) in St. Kitts and Nevis?
Provide a succinct answer. 4.83e+09. What is the ratio of the Taxes (in US$) in Aruba in 1995 to that in 1996?
Offer a very short reply. 0.95. What is the ratio of the Taxes (in US$) of Croatia in 1995 to that in 1996?
Offer a very short reply. 0.98. What is the ratio of the Taxes (in US$) in Ethiopia in 1995 to that in 1996?
Provide a short and direct response. 0.87. What is the ratio of the Taxes (in US$) of St. Kitts and Nevis in 1995 to that in 1996?
Ensure brevity in your answer.  0.9. What is the ratio of the Taxes (in US$) of Aruba in 1995 to that in 1997?
Your answer should be compact. 0.91. What is the ratio of the Taxes (in US$) of Croatia in 1995 to that in 1997?
Make the answer very short. 0.85. What is the ratio of the Taxes (in US$) of Ethiopia in 1995 to that in 1997?
Provide a succinct answer. 0.76. What is the ratio of the Taxes (in US$) of St. Kitts and Nevis in 1995 to that in 1997?
Ensure brevity in your answer.  0.8. What is the ratio of the Taxes (in US$) in Aruba in 1995 to that in 1998?
Your response must be concise. 0.88. What is the ratio of the Taxes (in US$) in Croatia in 1995 to that in 1998?
Provide a short and direct response. 0.73. What is the ratio of the Taxes (in US$) of Ethiopia in 1995 to that in 1998?
Give a very brief answer. 0.77. What is the ratio of the Taxes (in US$) in St. Kitts and Nevis in 1995 to that in 1998?
Your answer should be compact. 0.77. What is the ratio of the Taxes (in US$) of Aruba in 1995 to that in 1999?
Provide a short and direct response. 0.81. What is the ratio of the Taxes (in US$) of Croatia in 1995 to that in 1999?
Offer a terse response. 0.73. What is the ratio of the Taxes (in US$) of Ethiopia in 1995 to that in 1999?
Offer a terse response. 0.73. What is the ratio of the Taxes (in US$) in St. Kitts and Nevis in 1995 to that in 1999?
Ensure brevity in your answer.  0.73. What is the ratio of the Taxes (in US$) in Aruba in 1995 to that in 2000?
Give a very brief answer. 0.81. What is the ratio of the Taxes (in US$) of Croatia in 1995 to that in 2000?
Make the answer very short. 0.65. What is the ratio of the Taxes (in US$) of Ethiopia in 1995 to that in 2000?
Make the answer very short. 0.62. What is the ratio of the Taxes (in US$) of St. Kitts and Nevis in 1995 to that in 2000?
Provide a succinct answer. 0.8. What is the ratio of the Taxes (in US$) of Aruba in 1995 to that in 2001?
Your answer should be very brief. 0.81. What is the ratio of the Taxes (in US$) in Croatia in 1995 to that in 2001?
Your answer should be very brief. 0.6. What is the ratio of the Taxes (in US$) in Ethiopia in 1995 to that in 2001?
Ensure brevity in your answer.  0.55. What is the ratio of the Taxes (in US$) of St. Kitts and Nevis in 1995 to that in 2001?
Give a very brief answer. 0.75. What is the ratio of the Taxes (in US$) of Aruba in 1996 to that in 1997?
Your answer should be compact. 0.97. What is the ratio of the Taxes (in US$) in Croatia in 1996 to that in 1997?
Your answer should be compact. 0.87. What is the ratio of the Taxes (in US$) in Ethiopia in 1996 to that in 1997?
Your answer should be very brief. 0.87. What is the ratio of the Taxes (in US$) in St. Kitts and Nevis in 1996 to that in 1997?
Your response must be concise. 0.89. What is the ratio of the Taxes (in US$) of Aruba in 1996 to that in 1998?
Keep it short and to the point. 0.93. What is the ratio of the Taxes (in US$) of Croatia in 1996 to that in 1998?
Your answer should be very brief. 0.75. What is the ratio of the Taxes (in US$) of Ethiopia in 1996 to that in 1998?
Ensure brevity in your answer.  0.89. What is the ratio of the Taxes (in US$) in St. Kitts and Nevis in 1996 to that in 1998?
Your answer should be compact. 0.85. What is the ratio of the Taxes (in US$) in Aruba in 1996 to that in 1999?
Provide a short and direct response. 0.85. What is the ratio of the Taxes (in US$) in Croatia in 1996 to that in 1999?
Your answer should be very brief. 0.75. What is the ratio of the Taxes (in US$) of Ethiopia in 1996 to that in 1999?
Make the answer very short. 0.83. What is the ratio of the Taxes (in US$) of St. Kitts and Nevis in 1996 to that in 1999?
Keep it short and to the point. 0.82. What is the ratio of the Taxes (in US$) of Aruba in 1996 to that in 2000?
Give a very brief answer. 0.85. What is the ratio of the Taxes (in US$) in Croatia in 1996 to that in 2000?
Offer a terse response. 0.66. What is the ratio of the Taxes (in US$) in Ethiopia in 1996 to that in 2000?
Your response must be concise. 0.72. What is the ratio of the Taxes (in US$) of St. Kitts and Nevis in 1996 to that in 2000?
Provide a short and direct response. 0.89. What is the ratio of the Taxes (in US$) of Aruba in 1996 to that in 2001?
Keep it short and to the point. 0.86. What is the ratio of the Taxes (in US$) in Croatia in 1996 to that in 2001?
Offer a terse response. 0.61. What is the ratio of the Taxes (in US$) in Ethiopia in 1996 to that in 2001?
Your response must be concise. 0.63. What is the ratio of the Taxes (in US$) in St. Kitts and Nevis in 1996 to that in 2001?
Your response must be concise. 0.83. What is the ratio of the Taxes (in US$) of Aruba in 1997 to that in 1998?
Offer a terse response. 0.96. What is the ratio of the Taxes (in US$) of Croatia in 1997 to that in 1998?
Give a very brief answer. 0.86. What is the ratio of the Taxes (in US$) in St. Kitts and Nevis in 1997 to that in 1998?
Ensure brevity in your answer.  0.96. What is the ratio of the Taxes (in US$) in Aruba in 1997 to that in 1999?
Your response must be concise. 0.89. What is the ratio of the Taxes (in US$) of Croatia in 1997 to that in 1999?
Offer a very short reply. 0.86. What is the ratio of the Taxes (in US$) in Ethiopia in 1997 to that in 1999?
Make the answer very short. 0.96. What is the ratio of the Taxes (in US$) in St. Kitts and Nevis in 1997 to that in 1999?
Offer a very short reply. 0.92. What is the ratio of the Taxes (in US$) of Aruba in 1997 to that in 2000?
Offer a terse response. 0.89. What is the ratio of the Taxes (in US$) of Croatia in 1997 to that in 2000?
Make the answer very short. 0.76. What is the ratio of the Taxes (in US$) of Ethiopia in 1997 to that in 2000?
Provide a short and direct response. 0.82. What is the ratio of the Taxes (in US$) of St. Kitts and Nevis in 1997 to that in 2000?
Keep it short and to the point. 1. What is the ratio of the Taxes (in US$) of Aruba in 1997 to that in 2001?
Ensure brevity in your answer.  0.89. What is the ratio of the Taxes (in US$) in Croatia in 1997 to that in 2001?
Your answer should be very brief. 0.7. What is the ratio of the Taxes (in US$) in Ethiopia in 1997 to that in 2001?
Give a very brief answer. 0.72. What is the ratio of the Taxes (in US$) in St. Kitts and Nevis in 1997 to that in 2001?
Make the answer very short. 0.94. What is the ratio of the Taxes (in US$) in Aruba in 1998 to that in 1999?
Your response must be concise. 0.92. What is the ratio of the Taxes (in US$) in Croatia in 1998 to that in 1999?
Give a very brief answer. 1. What is the ratio of the Taxes (in US$) of Ethiopia in 1998 to that in 1999?
Your answer should be very brief. 0.94. What is the ratio of the Taxes (in US$) of St. Kitts and Nevis in 1998 to that in 1999?
Your answer should be compact. 0.96. What is the ratio of the Taxes (in US$) in Aruba in 1998 to that in 2000?
Your response must be concise. 0.92. What is the ratio of the Taxes (in US$) in Croatia in 1998 to that in 2000?
Give a very brief answer. 0.88. What is the ratio of the Taxes (in US$) in Ethiopia in 1998 to that in 2000?
Your answer should be compact. 0.81. What is the ratio of the Taxes (in US$) of St. Kitts and Nevis in 1998 to that in 2000?
Your answer should be very brief. 1.04. What is the ratio of the Taxes (in US$) in Aruba in 1998 to that in 2001?
Provide a short and direct response. 0.92. What is the ratio of the Taxes (in US$) of Croatia in 1998 to that in 2001?
Your answer should be very brief. 0.81. What is the ratio of the Taxes (in US$) in Ethiopia in 1998 to that in 2001?
Your answer should be very brief. 0.71. What is the ratio of the Taxes (in US$) in St. Kitts and Nevis in 1998 to that in 2001?
Provide a succinct answer. 0.97. What is the ratio of the Taxes (in US$) of Aruba in 1999 to that in 2000?
Offer a very short reply. 1. What is the ratio of the Taxes (in US$) of Croatia in 1999 to that in 2000?
Keep it short and to the point. 0.88. What is the ratio of the Taxes (in US$) in Ethiopia in 1999 to that in 2000?
Provide a short and direct response. 0.86. What is the ratio of the Taxes (in US$) in St. Kitts and Nevis in 1999 to that in 2000?
Give a very brief answer. 1.09. What is the ratio of the Taxes (in US$) in Aruba in 1999 to that in 2001?
Ensure brevity in your answer.  1. What is the ratio of the Taxes (in US$) of Croatia in 1999 to that in 2001?
Your response must be concise. 0.81. What is the ratio of the Taxes (in US$) in Ethiopia in 1999 to that in 2001?
Make the answer very short. 0.75. What is the ratio of the Taxes (in US$) of St. Kitts and Nevis in 1999 to that in 2001?
Your answer should be compact. 1.02. What is the ratio of the Taxes (in US$) in Aruba in 2000 to that in 2001?
Provide a succinct answer. 1. What is the ratio of the Taxes (in US$) in Croatia in 2000 to that in 2001?
Ensure brevity in your answer.  0.93. What is the ratio of the Taxes (in US$) in Ethiopia in 2000 to that in 2001?
Your answer should be very brief. 0.88. What is the ratio of the Taxes (in US$) of St. Kitts and Nevis in 2000 to that in 2001?
Provide a short and direct response. 0.94. What is the difference between the highest and the second highest Taxes (in US$) in Croatia?
Offer a terse response. 2.44e+09. What is the difference between the highest and the second highest Taxes (in US$) in Ethiopia?
Offer a very short reply. 6.09e+08. What is the difference between the highest and the second highest Taxes (in US$) of St. Kitts and Nevis?
Your answer should be very brief. 2.08e+06. What is the difference between the highest and the lowest Taxes (in US$) of Aruba?
Provide a succinct answer. 4.98e+07. What is the difference between the highest and the lowest Taxes (in US$) in Croatia?
Keep it short and to the point. 1.31e+1. What is the difference between the highest and the lowest Taxes (in US$) in Ethiopia?
Ensure brevity in your answer.  2.25e+09. What is the difference between the highest and the lowest Taxes (in US$) of St. Kitts and Nevis?
Give a very brief answer. 3.42e+07. 